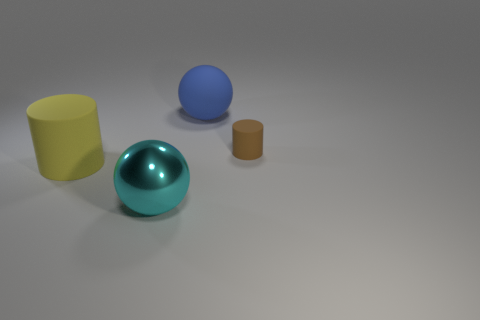Are there any other things that are the same size as the brown matte thing?
Your answer should be compact. No. Is the number of big matte balls that are in front of the metal object less than the number of balls that are on the left side of the large blue matte object?
Provide a short and direct response. Yes. How big is the cylinder that is left of the big ball that is in front of the big rubber object behind the small brown matte cylinder?
Your answer should be compact. Large. There is a thing left of the cyan object; does it have the same size as the big blue sphere?
Make the answer very short. Yes. What number of other objects are there of the same material as the yellow cylinder?
Provide a succinct answer. 2. Are there more matte objects than brown things?
Provide a succinct answer. Yes. What is the material of the big thing to the left of the large thing that is in front of the thing on the left side of the large shiny ball?
Your answer should be compact. Rubber. There is a blue object that is the same size as the metallic ball; what is its shape?
Give a very brief answer. Sphere. Is the number of yellow cylinders less than the number of matte cylinders?
Make the answer very short. Yes. How many blue things have the same size as the brown cylinder?
Give a very brief answer. 0. 